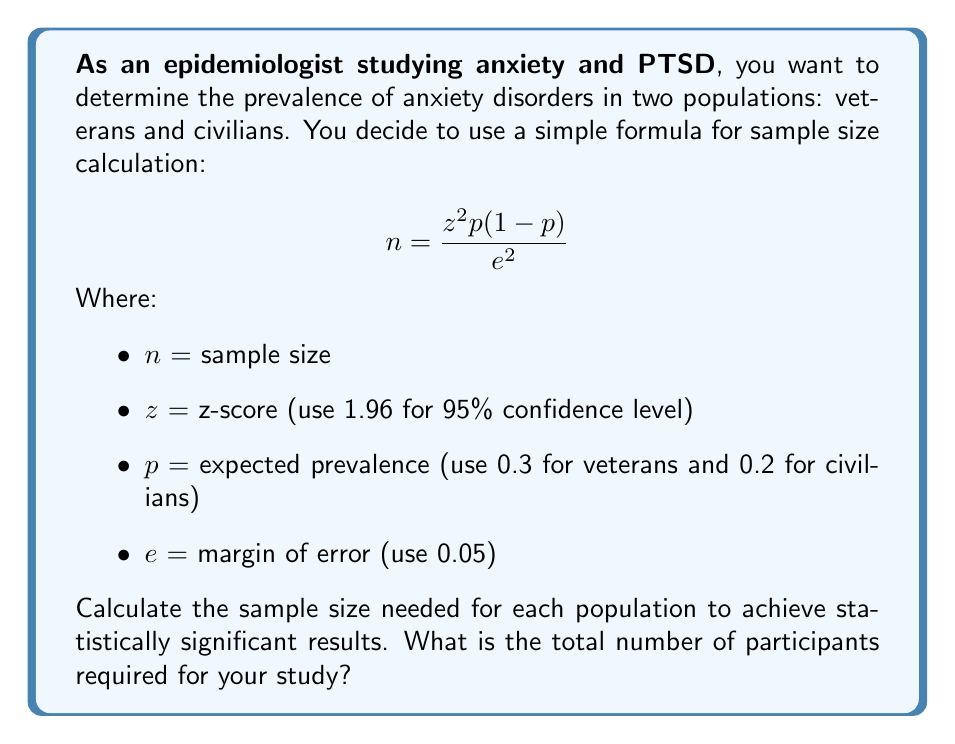Can you solve this math problem? To solve this problem, we need to calculate the sample size for each population separately using the given formula, then add them together.

For veterans:
$$ n_{veterans} = \frac{1.96^2 \times 0.3(1-0.3)}{0.05^2} $$
$$ n_{veterans} = \frac{3.8416 \times 0.3 \times 0.7}{0.0025} $$
$$ n_{veterans} = \frac{0.80674}{0.0025} $$
$$ n_{veterans} = 322.696 $$
Rounding up, we need 323 veterans.

For civilians:
$$ n_{civilians} = \frac{1.96^2 \times 0.2(1-0.2)}{0.05^2} $$
$$ n_{civilians} = \frac{3.8416 \times 0.2 \times 0.8}{0.0025} $$
$$ n_{civilians} = \frac{0.61466}{0.0025} $$
$$ n_{civilians} = 245.864 $$
Rounding up, we need 246 civilians.

To get the total number of participants, we add the two sample sizes:

Total participants = 323 + 246 = 569
Answer: 569 participants 